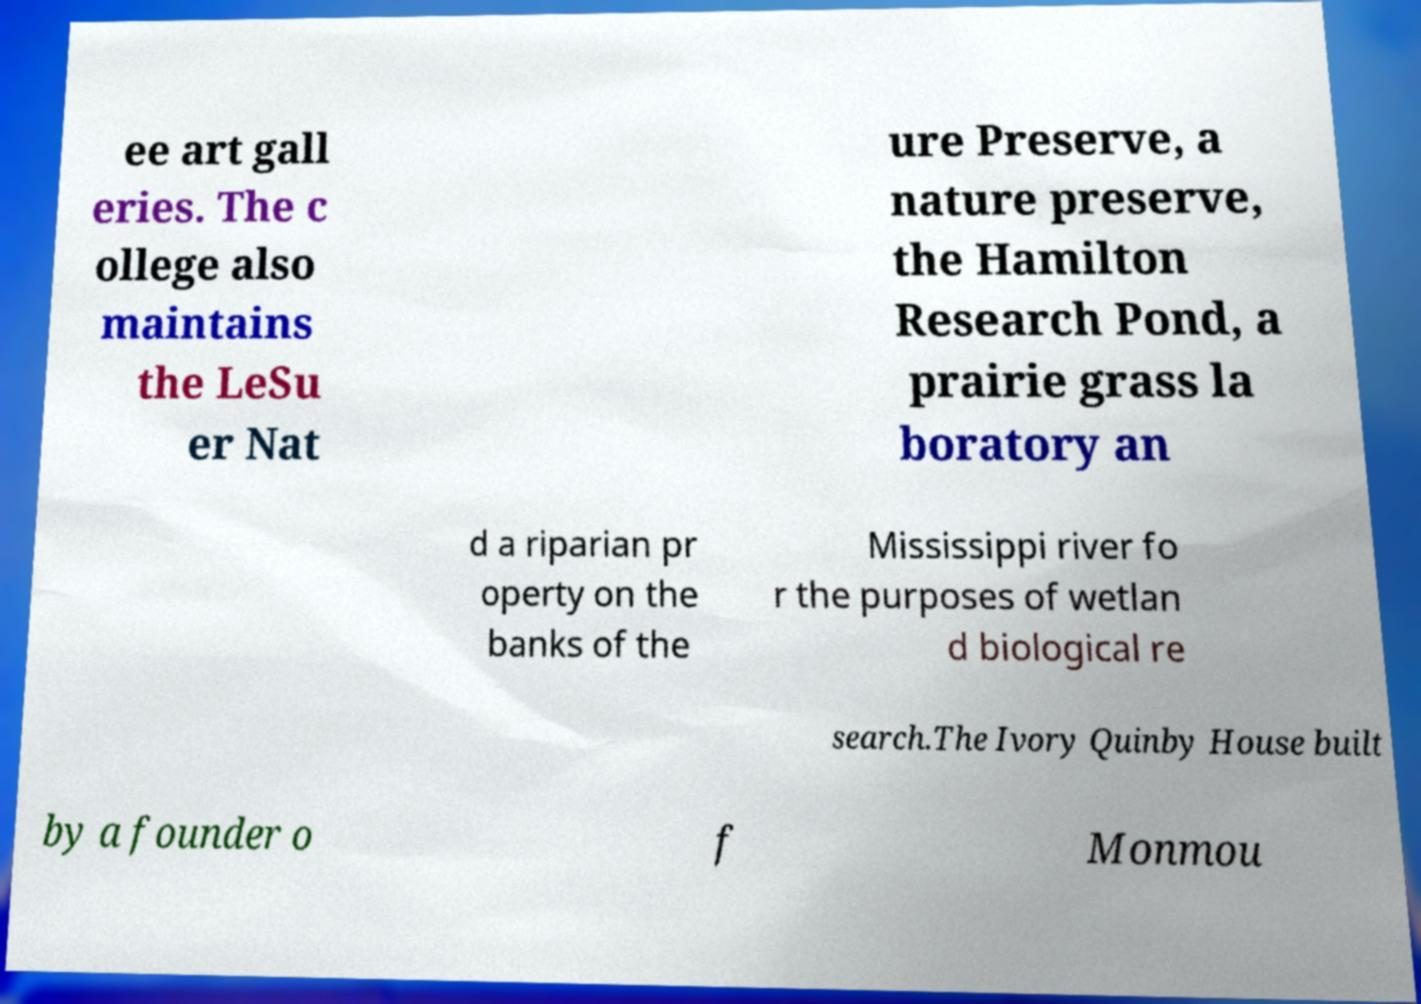For documentation purposes, I need the text within this image transcribed. Could you provide that? ee art gall eries. The c ollege also maintains the LeSu er Nat ure Preserve, a nature preserve, the Hamilton Research Pond, a prairie grass la boratory an d a riparian pr operty on the banks of the Mississippi river fo r the purposes of wetlan d biological re search.The Ivory Quinby House built by a founder o f Monmou 